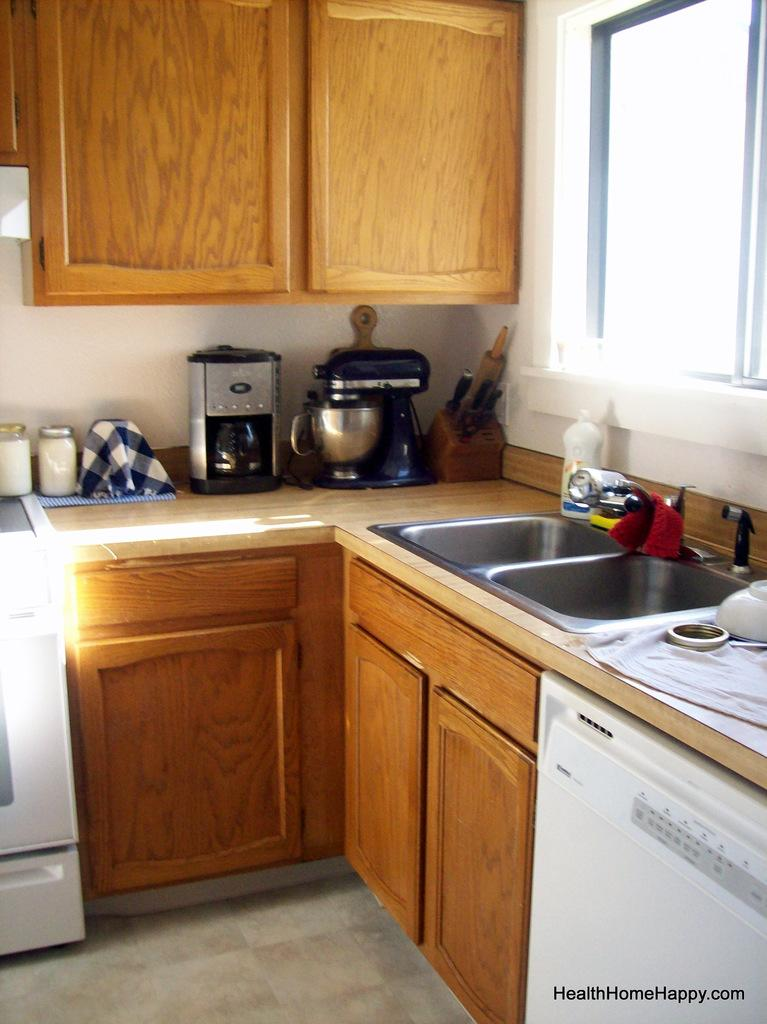What type of furniture is present in the image? There is a kitchen cabinet in the image. What features does the kitchen cabinet have? The kitchen cabinet has a sink and a tap. What items can be seen in the image besides the kitchen cabinet? There are bottles, machines, bowls, and cupboards in the image. Can you describe the cupboards in the image? The cupboards are attached to the wall and have a window. What type of creature is standing guard in the image? There is no creature present in the image. What position does the army hold in the image? There is no army or position related to an army in the image. 